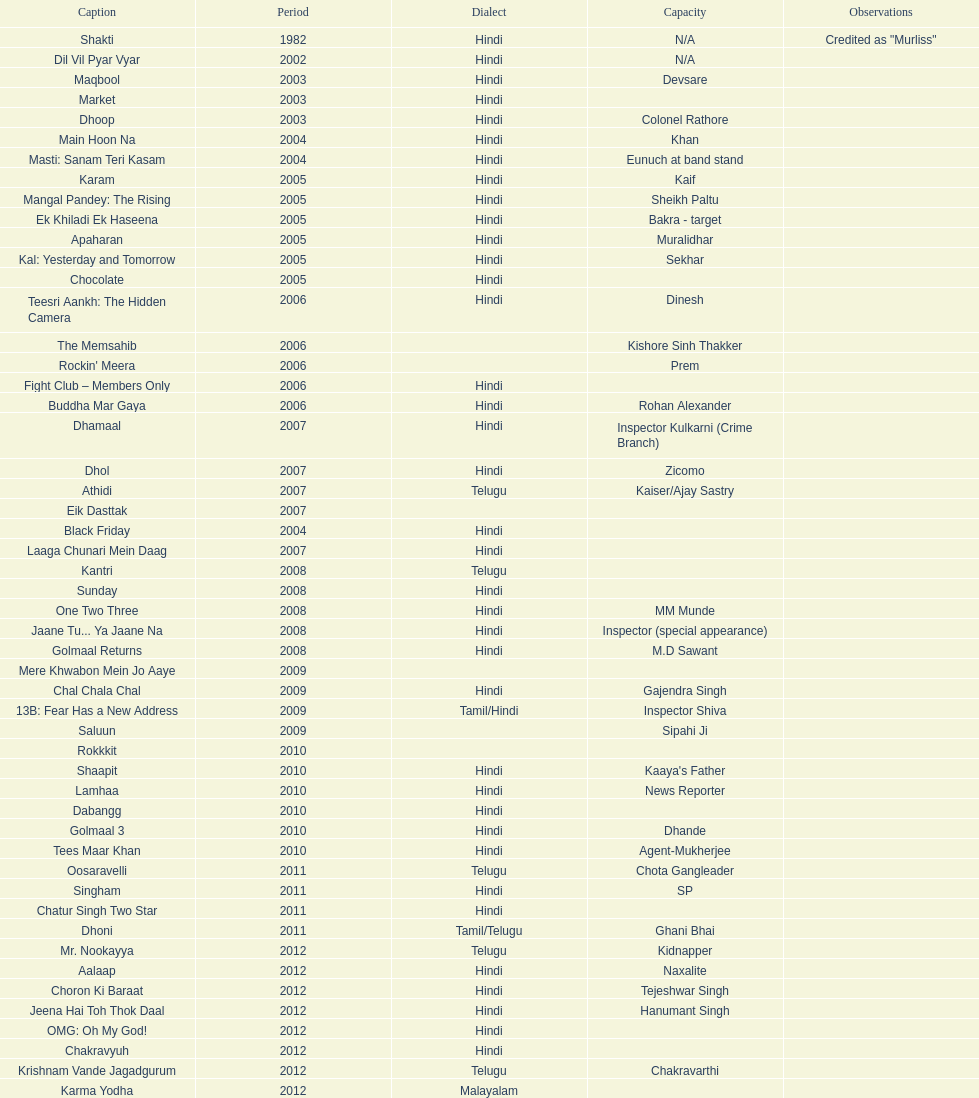Does maqbool have longer notes than shakti? No. 